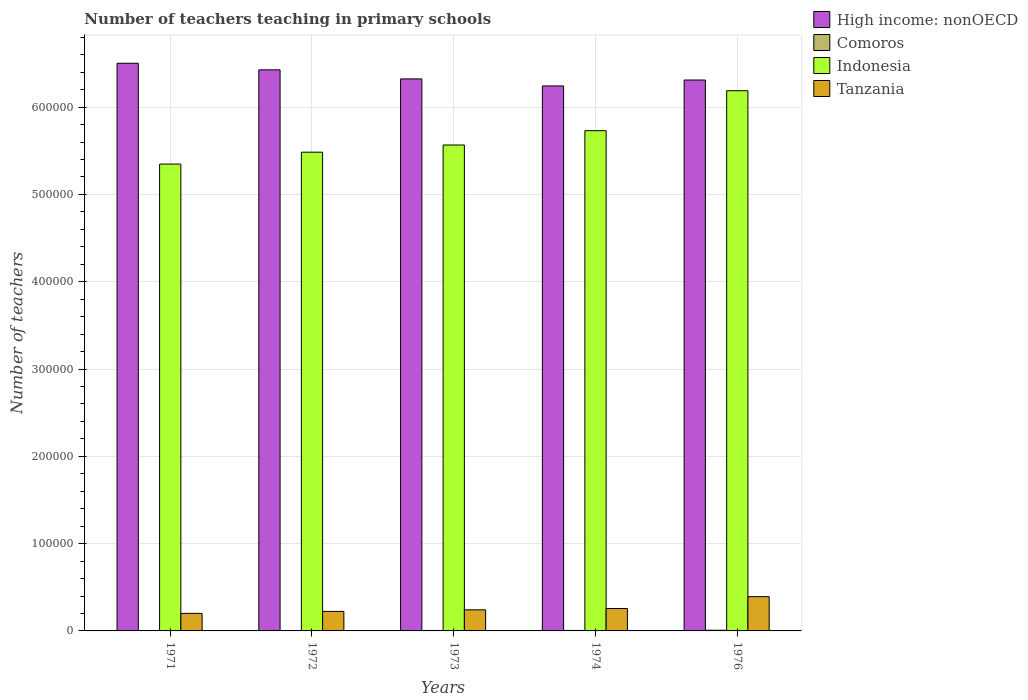Are the number of bars per tick equal to the number of legend labels?
Offer a terse response. Yes. Are the number of bars on each tick of the X-axis equal?
Provide a short and direct response. Yes. What is the label of the 2nd group of bars from the left?
Provide a short and direct response. 1972. In how many cases, is the number of bars for a given year not equal to the number of legend labels?
Ensure brevity in your answer.  0. What is the number of teachers teaching in primary schools in Comoros in 1972?
Provide a succinct answer. 396. Across all years, what is the maximum number of teachers teaching in primary schools in Indonesia?
Give a very brief answer. 6.19e+05. Across all years, what is the minimum number of teachers teaching in primary schools in Comoros?
Your answer should be compact. 361. In which year was the number of teachers teaching in primary schools in Indonesia maximum?
Your answer should be compact. 1976. What is the total number of teachers teaching in primary schools in High income: nonOECD in the graph?
Provide a short and direct response. 3.18e+06. What is the difference between the number of teachers teaching in primary schools in Comoros in 1971 and that in 1973?
Provide a succinct answer. -172. What is the difference between the number of teachers teaching in primary schools in Tanzania in 1976 and the number of teachers teaching in primary schools in High income: nonOECD in 1974?
Your answer should be compact. -5.85e+05. What is the average number of teachers teaching in primary schools in High income: nonOECD per year?
Your answer should be compact. 6.36e+05. In the year 1972, what is the difference between the number of teachers teaching in primary schools in Tanzania and number of teachers teaching in primary schools in High income: nonOECD?
Offer a terse response. -6.20e+05. What is the ratio of the number of teachers teaching in primary schools in Tanzania in 1972 to that in 1974?
Offer a very short reply. 0.87. Is the difference between the number of teachers teaching in primary schools in Tanzania in 1973 and 1976 greater than the difference between the number of teachers teaching in primary schools in High income: nonOECD in 1973 and 1976?
Ensure brevity in your answer.  No. What is the difference between the highest and the second highest number of teachers teaching in primary schools in Comoros?
Offer a very short reply. 202. What is the difference between the highest and the lowest number of teachers teaching in primary schools in Tanzania?
Keep it short and to the point. 1.92e+04. What does the 2nd bar from the left in 1972 represents?
Provide a short and direct response. Comoros. What does the 4th bar from the right in 1971 represents?
Provide a succinct answer. High income: nonOECD. Are all the bars in the graph horizontal?
Ensure brevity in your answer.  No. How many years are there in the graph?
Make the answer very short. 5. Are the values on the major ticks of Y-axis written in scientific E-notation?
Provide a short and direct response. No. Does the graph contain any zero values?
Provide a short and direct response. No. Where does the legend appear in the graph?
Your response must be concise. Top right. How many legend labels are there?
Your response must be concise. 4. What is the title of the graph?
Provide a short and direct response. Number of teachers teaching in primary schools. What is the label or title of the X-axis?
Your answer should be very brief. Years. What is the label or title of the Y-axis?
Keep it short and to the point. Number of teachers. What is the Number of teachers in High income: nonOECD in 1971?
Your answer should be compact. 6.50e+05. What is the Number of teachers in Comoros in 1971?
Make the answer very short. 361. What is the Number of teachers in Indonesia in 1971?
Your answer should be very brief. 5.35e+05. What is the Number of teachers of Tanzania in 1971?
Your response must be concise. 2.01e+04. What is the Number of teachers in High income: nonOECD in 1972?
Your answer should be compact. 6.43e+05. What is the Number of teachers in Comoros in 1972?
Keep it short and to the point. 396. What is the Number of teachers in Indonesia in 1972?
Make the answer very short. 5.48e+05. What is the Number of teachers of Tanzania in 1972?
Provide a succinct answer. 2.24e+04. What is the Number of teachers in High income: nonOECD in 1973?
Keep it short and to the point. 6.32e+05. What is the Number of teachers in Comoros in 1973?
Provide a succinct answer. 533. What is the Number of teachers of Indonesia in 1973?
Offer a very short reply. 5.57e+05. What is the Number of teachers of Tanzania in 1973?
Ensure brevity in your answer.  2.42e+04. What is the Number of teachers of High income: nonOECD in 1974?
Keep it short and to the point. 6.24e+05. What is the Number of teachers of Comoros in 1974?
Provide a short and direct response. 554. What is the Number of teachers of Indonesia in 1974?
Keep it short and to the point. 5.73e+05. What is the Number of teachers in Tanzania in 1974?
Offer a terse response. 2.57e+04. What is the Number of teachers in High income: nonOECD in 1976?
Your response must be concise. 6.31e+05. What is the Number of teachers of Comoros in 1976?
Ensure brevity in your answer.  756. What is the Number of teachers of Indonesia in 1976?
Make the answer very short. 6.19e+05. What is the Number of teachers in Tanzania in 1976?
Provide a short and direct response. 3.92e+04. Across all years, what is the maximum Number of teachers of High income: nonOECD?
Give a very brief answer. 6.50e+05. Across all years, what is the maximum Number of teachers in Comoros?
Provide a succinct answer. 756. Across all years, what is the maximum Number of teachers of Indonesia?
Keep it short and to the point. 6.19e+05. Across all years, what is the maximum Number of teachers in Tanzania?
Provide a short and direct response. 3.92e+04. Across all years, what is the minimum Number of teachers in High income: nonOECD?
Provide a succinct answer. 6.24e+05. Across all years, what is the minimum Number of teachers in Comoros?
Provide a succinct answer. 361. Across all years, what is the minimum Number of teachers of Indonesia?
Ensure brevity in your answer.  5.35e+05. Across all years, what is the minimum Number of teachers in Tanzania?
Ensure brevity in your answer.  2.01e+04. What is the total Number of teachers of High income: nonOECD in the graph?
Keep it short and to the point. 3.18e+06. What is the total Number of teachers in Comoros in the graph?
Ensure brevity in your answer.  2600. What is the total Number of teachers of Indonesia in the graph?
Give a very brief answer. 2.83e+06. What is the total Number of teachers of Tanzania in the graph?
Give a very brief answer. 1.32e+05. What is the difference between the Number of teachers of High income: nonOECD in 1971 and that in 1972?
Give a very brief answer. 7545.62. What is the difference between the Number of teachers of Comoros in 1971 and that in 1972?
Provide a succinct answer. -35. What is the difference between the Number of teachers in Indonesia in 1971 and that in 1972?
Offer a very short reply. -1.36e+04. What is the difference between the Number of teachers in Tanzania in 1971 and that in 1972?
Ensure brevity in your answer.  -2266. What is the difference between the Number of teachers in High income: nonOECD in 1971 and that in 1973?
Your answer should be compact. 1.79e+04. What is the difference between the Number of teachers of Comoros in 1971 and that in 1973?
Keep it short and to the point. -172. What is the difference between the Number of teachers of Indonesia in 1971 and that in 1973?
Make the answer very short. -2.19e+04. What is the difference between the Number of teachers in Tanzania in 1971 and that in 1973?
Give a very brief answer. -4074. What is the difference between the Number of teachers in High income: nonOECD in 1971 and that in 1974?
Your response must be concise. 2.60e+04. What is the difference between the Number of teachers of Comoros in 1971 and that in 1974?
Your answer should be compact. -193. What is the difference between the Number of teachers of Indonesia in 1971 and that in 1974?
Offer a terse response. -3.83e+04. What is the difference between the Number of teachers in Tanzania in 1971 and that in 1974?
Your response must be concise. -5594. What is the difference between the Number of teachers in High income: nonOECD in 1971 and that in 1976?
Make the answer very short. 1.92e+04. What is the difference between the Number of teachers of Comoros in 1971 and that in 1976?
Make the answer very short. -395. What is the difference between the Number of teachers of Indonesia in 1971 and that in 1976?
Provide a short and direct response. -8.40e+04. What is the difference between the Number of teachers in Tanzania in 1971 and that in 1976?
Offer a terse response. -1.92e+04. What is the difference between the Number of teachers in High income: nonOECD in 1972 and that in 1973?
Provide a succinct answer. 1.04e+04. What is the difference between the Number of teachers in Comoros in 1972 and that in 1973?
Offer a very short reply. -137. What is the difference between the Number of teachers of Indonesia in 1972 and that in 1973?
Offer a terse response. -8228. What is the difference between the Number of teachers in Tanzania in 1972 and that in 1973?
Make the answer very short. -1808. What is the difference between the Number of teachers in High income: nonOECD in 1972 and that in 1974?
Offer a very short reply. 1.85e+04. What is the difference between the Number of teachers in Comoros in 1972 and that in 1974?
Provide a succinct answer. -158. What is the difference between the Number of teachers in Indonesia in 1972 and that in 1974?
Offer a terse response. -2.46e+04. What is the difference between the Number of teachers in Tanzania in 1972 and that in 1974?
Your answer should be compact. -3328. What is the difference between the Number of teachers of High income: nonOECD in 1972 and that in 1976?
Offer a very short reply. 1.17e+04. What is the difference between the Number of teachers in Comoros in 1972 and that in 1976?
Your answer should be very brief. -360. What is the difference between the Number of teachers in Indonesia in 1972 and that in 1976?
Your response must be concise. -7.04e+04. What is the difference between the Number of teachers of Tanzania in 1972 and that in 1976?
Keep it short and to the point. -1.69e+04. What is the difference between the Number of teachers of High income: nonOECD in 1973 and that in 1974?
Your answer should be very brief. 8076.81. What is the difference between the Number of teachers in Comoros in 1973 and that in 1974?
Make the answer very short. -21. What is the difference between the Number of teachers of Indonesia in 1973 and that in 1974?
Offer a terse response. -1.64e+04. What is the difference between the Number of teachers of Tanzania in 1973 and that in 1974?
Offer a terse response. -1520. What is the difference between the Number of teachers in High income: nonOECD in 1973 and that in 1976?
Offer a very short reply. 1283.31. What is the difference between the Number of teachers in Comoros in 1973 and that in 1976?
Give a very brief answer. -223. What is the difference between the Number of teachers in Indonesia in 1973 and that in 1976?
Provide a short and direct response. -6.22e+04. What is the difference between the Number of teachers of Tanzania in 1973 and that in 1976?
Your answer should be very brief. -1.51e+04. What is the difference between the Number of teachers of High income: nonOECD in 1974 and that in 1976?
Your answer should be very brief. -6793.5. What is the difference between the Number of teachers of Comoros in 1974 and that in 1976?
Give a very brief answer. -202. What is the difference between the Number of teachers in Indonesia in 1974 and that in 1976?
Offer a very short reply. -4.58e+04. What is the difference between the Number of teachers of Tanzania in 1974 and that in 1976?
Offer a very short reply. -1.36e+04. What is the difference between the Number of teachers in High income: nonOECD in 1971 and the Number of teachers in Comoros in 1972?
Offer a terse response. 6.50e+05. What is the difference between the Number of teachers in High income: nonOECD in 1971 and the Number of teachers in Indonesia in 1972?
Ensure brevity in your answer.  1.02e+05. What is the difference between the Number of teachers of High income: nonOECD in 1971 and the Number of teachers of Tanzania in 1972?
Offer a very short reply. 6.28e+05. What is the difference between the Number of teachers in Comoros in 1971 and the Number of teachers in Indonesia in 1972?
Your answer should be very brief. -5.48e+05. What is the difference between the Number of teachers of Comoros in 1971 and the Number of teachers of Tanzania in 1972?
Ensure brevity in your answer.  -2.20e+04. What is the difference between the Number of teachers of Indonesia in 1971 and the Number of teachers of Tanzania in 1972?
Your response must be concise. 5.12e+05. What is the difference between the Number of teachers in High income: nonOECD in 1971 and the Number of teachers in Comoros in 1973?
Give a very brief answer. 6.50e+05. What is the difference between the Number of teachers in High income: nonOECD in 1971 and the Number of teachers in Indonesia in 1973?
Your answer should be very brief. 9.36e+04. What is the difference between the Number of teachers of High income: nonOECD in 1971 and the Number of teachers of Tanzania in 1973?
Your response must be concise. 6.26e+05. What is the difference between the Number of teachers of Comoros in 1971 and the Number of teachers of Indonesia in 1973?
Make the answer very short. -5.56e+05. What is the difference between the Number of teachers in Comoros in 1971 and the Number of teachers in Tanzania in 1973?
Provide a succinct answer. -2.38e+04. What is the difference between the Number of teachers of Indonesia in 1971 and the Number of teachers of Tanzania in 1973?
Your answer should be compact. 5.11e+05. What is the difference between the Number of teachers in High income: nonOECD in 1971 and the Number of teachers in Comoros in 1974?
Provide a short and direct response. 6.50e+05. What is the difference between the Number of teachers of High income: nonOECD in 1971 and the Number of teachers of Indonesia in 1974?
Make the answer very short. 7.72e+04. What is the difference between the Number of teachers of High income: nonOECD in 1971 and the Number of teachers of Tanzania in 1974?
Ensure brevity in your answer.  6.25e+05. What is the difference between the Number of teachers of Comoros in 1971 and the Number of teachers of Indonesia in 1974?
Provide a succinct answer. -5.73e+05. What is the difference between the Number of teachers in Comoros in 1971 and the Number of teachers in Tanzania in 1974?
Your answer should be compact. -2.53e+04. What is the difference between the Number of teachers of Indonesia in 1971 and the Number of teachers of Tanzania in 1974?
Your answer should be very brief. 5.09e+05. What is the difference between the Number of teachers of High income: nonOECD in 1971 and the Number of teachers of Comoros in 1976?
Offer a terse response. 6.50e+05. What is the difference between the Number of teachers in High income: nonOECD in 1971 and the Number of teachers in Indonesia in 1976?
Keep it short and to the point. 3.15e+04. What is the difference between the Number of teachers in High income: nonOECD in 1971 and the Number of teachers in Tanzania in 1976?
Give a very brief answer. 6.11e+05. What is the difference between the Number of teachers of Comoros in 1971 and the Number of teachers of Indonesia in 1976?
Provide a succinct answer. -6.18e+05. What is the difference between the Number of teachers of Comoros in 1971 and the Number of teachers of Tanzania in 1976?
Your answer should be very brief. -3.89e+04. What is the difference between the Number of teachers in Indonesia in 1971 and the Number of teachers in Tanzania in 1976?
Give a very brief answer. 4.96e+05. What is the difference between the Number of teachers in High income: nonOECD in 1972 and the Number of teachers in Comoros in 1973?
Provide a succinct answer. 6.42e+05. What is the difference between the Number of teachers in High income: nonOECD in 1972 and the Number of teachers in Indonesia in 1973?
Provide a short and direct response. 8.61e+04. What is the difference between the Number of teachers of High income: nonOECD in 1972 and the Number of teachers of Tanzania in 1973?
Your answer should be compact. 6.19e+05. What is the difference between the Number of teachers in Comoros in 1972 and the Number of teachers in Indonesia in 1973?
Offer a very short reply. -5.56e+05. What is the difference between the Number of teachers in Comoros in 1972 and the Number of teachers in Tanzania in 1973?
Make the answer very short. -2.38e+04. What is the difference between the Number of teachers in Indonesia in 1972 and the Number of teachers in Tanzania in 1973?
Give a very brief answer. 5.24e+05. What is the difference between the Number of teachers in High income: nonOECD in 1972 and the Number of teachers in Comoros in 1974?
Your answer should be compact. 6.42e+05. What is the difference between the Number of teachers in High income: nonOECD in 1972 and the Number of teachers in Indonesia in 1974?
Your answer should be very brief. 6.97e+04. What is the difference between the Number of teachers in High income: nonOECD in 1972 and the Number of teachers in Tanzania in 1974?
Make the answer very short. 6.17e+05. What is the difference between the Number of teachers of Comoros in 1972 and the Number of teachers of Indonesia in 1974?
Offer a terse response. -5.73e+05. What is the difference between the Number of teachers of Comoros in 1972 and the Number of teachers of Tanzania in 1974?
Keep it short and to the point. -2.53e+04. What is the difference between the Number of teachers of Indonesia in 1972 and the Number of teachers of Tanzania in 1974?
Offer a very short reply. 5.23e+05. What is the difference between the Number of teachers of High income: nonOECD in 1972 and the Number of teachers of Comoros in 1976?
Your response must be concise. 6.42e+05. What is the difference between the Number of teachers in High income: nonOECD in 1972 and the Number of teachers in Indonesia in 1976?
Your answer should be very brief. 2.39e+04. What is the difference between the Number of teachers in High income: nonOECD in 1972 and the Number of teachers in Tanzania in 1976?
Give a very brief answer. 6.04e+05. What is the difference between the Number of teachers in Comoros in 1972 and the Number of teachers in Indonesia in 1976?
Give a very brief answer. -6.18e+05. What is the difference between the Number of teachers of Comoros in 1972 and the Number of teachers of Tanzania in 1976?
Your answer should be compact. -3.88e+04. What is the difference between the Number of teachers of Indonesia in 1972 and the Number of teachers of Tanzania in 1976?
Make the answer very short. 5.09e+05. What is the difference between the Number of teachers in High income: nonOECD in 1973 and the Number of teachers in Comoros in 1974?
Provide a succinct answer. 6.32e+05. What is the difference between the Number of teachers in High income: nonOECD in 1973 and the Number of teachers in Indonesia in 1974?
Offer a very short reply. 5.93e+04. What is the difference between the Number of teachers in High income: nonOECD in 1973 and the Number of teachers in Tanzania in 1974?
Give a very brief answer. 6.07e+05. What is the difference between the Number of teachers in Comoros in 1973 and the Number of teachers in Indonesia in 1974?
Keep it short and to the point. -5.73e+05. What is the difference between the Number of teachers of Comoros in 1973 and the Number of teachers of Tanzania in 1974?
Your response must be concise. -2.52e+04. What is the difference between the Number of teachers in Indonesia in 1973 and the Number of teachers in Tanzania in 1974?
Provide a succinct answer. 5.31e+05. What is the difference between the Number of teachers in High income: nonOECD in 1973 and the Number of teachers in Comoros in 1976?
Provide a short and direct response. 6.32e+05. What is the difference between the Number of teachers of High income: nonOECD in 1973 and the Number of teachers of Indonesia in 1976?
Your answer should be compact. 1.35e+04. What is the difference between the Number of teachers in High income: nonOECD in 1973 and the Number of teachers in Tanzania in 1976?
Ensure brevity in your answer.  5.93e+05. What is the difference between the Number of teachers of Comoros in 1973 and the Number of teachers of Indonesia in 1976?
Make the answer very short. -6.18e+05. What is the difference between the Number of teachers in Comoros in 1973 and the Number of teachers in Tanzania in 1976?
Keep it short and to the point. -3.87e+04. What is the difference between the Number of teachers in Indonesia in 1973 and the Number of teachers in Tanzania in 1976?
Make the answer very short. 5.17e+05. What is the difference between the Number of teachers in High income: nonOECD in 1974 and the Number of teachers in Comoros in 1976?
Offer a very short reply. 6.24e+05. What is the difference between the Number of teachers of High income: nonOECD in 1974 and the Number of teachers of Indonesia in 1976?
Ensure brevity in your answer.  5467.06. What is the difference between the Number of teachers in High income: nonOECD in 1974 and the Number of teachers in Tanzania in 1976?
Your response must be concise. 5.85e+05. What is the difference between the Number of teachers of Comoros in 1974 and the Number of teachers of Indonesia in 1976?
Ensure brevity in your answer.  -6.18e+05. What is the difference between the Number of teachers in Comoros in 1974 and the Number of teachers in Tanzania in 1976?
Offer a terse response. -3.87e+04. What is the difference between the Number of teachers of Indonesia in 1974 and the Number of teachers of Tanzania in 1976?
Make the answer very short. 5.34e+05. What is the average Number of teachers of High income: nonOECD per year?
Make the answer very short. 6.36e+05. What is the average Number of teachers in Comoros per year?
Your response must be concise. 520. What is the average Number of teachers in Indonesia per year?
Make the answer very short. 5.66e+05. What is the average Number of teachers in Tanzania per year?
Your answer should be compact. 2.63e+04. In the year 1971, what is the difference between the Number of teachers in High income: nonOECD and Number of teachers in Comoros?
Provide a short and direct response. 6.50e+05. In the year 1971, what is the difference between the Number of teachers in High income: nonOECD and Number of teachers in Indonesia?
Make the answer very short. 1.15e+05. In the year 1971, what is the difference between the Number of teachers in High income: nonOECD and Number of teachers in Tanzania?
Provide a succinct answer. 6.30e+05. In the year 1971, what is the difference between the Number of teachers in Comoros and Number of teachers in Indonesia?
Your response must be concise. -5.34e+05. In the year 1971, what is the difference between the Number of teachers of Comoros and Number of teachers of Tanzania?
Your answer should be very brief. -1.97e+04. In the year 1971, what is the difference between the Number of teachers in Indonesia and Number of teachers in Tanzania?
Your answer should be very brief. 5.15e+05. In the year 1972, what is the difference between the Number of teachers in High income: nonOECD and Number of teachers in Comoros?
Your answer should be very brief. 6.42e+05. In the year 1972, what is the difference between the Number of teachers in High income: nonOECD and Number of teachers in Indonesia?
Your response must be concise. 9.43e+04. In the year 1972, what is the difference between the Number of teachers in High income: nonOECD and Number of teachers in Tanzania?
Your answer should be very brief. 6.20e+05. In the year 1972, what is the difference between the Number of teachers of Comoros and Number of teachers of Indonesia?
Your answer should be very brief. -5.48e+05. In the year 1972, what is the difference between the Number of teachers of Comoros and Number of teachers of Tanzania?
Give a very brief answer. -2.20e+04. In the year 1972, what is the difference between the Number of teachers of Indonesia and Number of teachers of Tanzania?
Your answer should be compact. 5.26e+05. In the year 1973, what is the difference between the Number of teachers in High income: nonOECD and Number of teachers in Comoros?
Provide a succinct answer. 6.32e+05. In the year 1973, what is the difference between the Number of teachers in High income: nonOECD and Number of teachers in Indonesia?
Give a very brief answer. 7.57e+04. In the year 1973, what is the difference between the Number of teachers in High income: nonOECD and Number of teachers in Tanzania?
Provide a succinct answer. 6.08e+05. In the year 1973, what is the difference between the Number of teachers in Comoros and Number of teachers in Indonesia?
Offer a terse response. -5.56e+05. In the year 1973, what is the difference between the Number of teachers of Comoros and Number of teachers of Tanzania?
Offer a terse response. -2.36e+04. In the year 1973, what is the difference between the Number of teachers of Indonesia and Number of teachers of Tanzania?
Keep it short and to the point. 5.32e+05. In the year 1974, what is the difference between the Number of teachers in High income: nonOECD and Number of teachers in Comoros?
Give a very brief answer. 6.24e+05. In the year 1974, what is the difference between the Number of teachers in High income: nonOECD and Number of teachers in Indonesia?
Your answer should be very brief. 5.12e+04. In the year 1974, what is the difference between the Number of teachers of High income: nonOECD and Number of teachers of Tanzania?
Make the answer very short. 5.99e+05. In the year 1974, what is the difference between the Number of teachers in Comoros and Number of teachers in Indonesia?
Make the answer very short. -5.73e+05. In the year 1974, what is the difference between the Number of teachers of Comoros and Number of teachers of Tanzania?
Provide a succinct answer. -2.51e+04. In the year 1974, what is the difference between the Number of teachers of Indonesia and Number of teachers of Tanzania?
Make the answer very short. 5.47e+05. In the year 1976, what is the difference between the Number of teachers of High income: nonOECD and Number of teachers of Comoros?
Offer a terse response. 6.30e+05. In the year 1976, what is the difference between the Number of teachers of High income: nonOECD and Number of teachers of Indonesia?
Your answer should be very brief. 1.23e+04. In the year 1976, what is the difference between the Number of teachers in High income: nonOECD and Number of teachers in Tanzania?
Give a very brief answer. 5.92e+05. In the year 1976, what is the difference between the Number of teachers of Comoros and Number of teachers of Indonesia?
Offer a very short reply. -6.18e+05. In the year 1976, what is the difference between the Number of teachers in Comoros and Number of teachers in Tanzania?
Your answer should be very brief. -3.85e+04. In the year 1976, what is the difference between the Number of teachers of Indonesia and Number of teachers of Tanzania?
Ensure brevity in your answer.  5.80e+05. What is the ratio of the Number of teachers in High income: nonOECD in 1971 to that in 1972?
Give a very brief answer. 1.01. What is the ratio of the Number of teachers of Comoros in 1971 to that in 1972?
Your answer should be very brief. 0.91. What is the ratio of the Number of teachers of Indonesia in 1971 to that in 1972?
Provide a short and direct response. 0.98. What is the ratio of the Number of teachers of Tanzania in 1971 to that in 1972?
Provide a succinct answer. 0.9. What is the ratio of the Number of teachers of High income: nonOECD in 1971 to that in 1973?
Your answer should be compact. 1.03. What is the ratio of the Number of teachers of Comoros in 1971 to that in 1973?
Provide a short and direct response. 0.68. What is the ratio of the Number of teachers of Indonesia in 1971 to that in 1973?
Offer a terse response. 0.96. What is the ratio of the Number of teachers in Tanzania in 1971 to that in 1973?
Keep it short and to the point. 0.83. What is the ratio of the Number of teachers of High income: nonOECD in 1971 to that in 1974?
Offer a very short reply. 1.04. What is the ratio of the Number of teachers of Comoros in 1971 to that in 1974?
Make the answer very short. 0.65. What is the ratio of the Number of teachers in Indonesia in 1971 to that in 1974?
Your response must be concise. 0.93. What is the ratio of the Number of teachers of Tanzania in 1971 to that in 1974?
Give a very brief answer. 0.78. What is the ratio of the Number of teachers of High income: nonOECD in 1971 to that in 1976?
Your answer should be compact. 1.03. What is the ratio of the Number of teachers in Comoros in 1971 to that in 1976?
Keep it short and to the point. 0.48. What is the ratio of the Number of teachers in Indonesia in 1971 to that in 1976?
Provide a succinct answer. 0.86. What is the ratio of the Number of teachers in Tanzania in 1971 to that in 1976?
Ensure brevity in your answer.  0.51. What is the ratio of the Number of teachers of High income: nonOECD in 1972 to that in 1973?
Ensure brevity in your answer.  1.02. What is the ratio of the Number of teachers in Comoros in 1972 to that in 1973?
Give a very brief answer. 0.74. What is the ratio of the Number of teachers in Indonesia in 1972 to that in 1973?
Give a very brief answer. 0.99. What is the ratio of the Number of teachers in Tanzania in 1972 to that in 1973?
Give a very brief answer. 0.93. What is the ratio of the Number of teachers in High income: nonOECD in 1972 to that in 1974?
Give a very brief answer. 1.03. What is the ratio of the Number of teachers in Comoros in 1972 to that in 1974?
Your response must be concise. 0.71. What is the ratio of the Number of teachers in Indonesia in 1972 to that in 1974?
Provide a short and direct response. 0.96. What is the ratio of the Number of teachers of Tanzania in 1972 to that in 1974?
Provide a succinct answer. 0.87. What is the ratio of the Number of teachers in High income: nonOECD in 1972 to that in 1976?
Provide a succinct answer. 1.02. What is the ratio of the Number of teachers in Comoros in 1972 to that in 1976?
Your response must be concise. 0.52. What is the ratio of the Number of teachers of Indonesia in 1972 to that in 1976?
Ensure brevity in your answer.  0.89. What is the ratio of the Number of teachers of Tanzania in 1972 to that in 1976?
Keep it short and to the point. 0.57. What is the ratio of the Number of teachers in High income: nonOECD in 1973 to that in 1974?
Provide a short and direct response. 1.01. What is the ratio of the Number of teachers of Comoros in 1973 to that in 1974?
Offer a terse response. 0.96. What is the ratio of the Number of teachers in Indonesia in 1973 to that in 1974?
Keep it short and to the point. 0.97. What is the ratio of the Number of teachers of Tanzania in 1973 to that in 1974?
Provide a short and direct response. 0.94. What is the ratio of the Number of teachers of High income: nonOECD in 1973 to that in 1976?
Your answer should be compact. 1. What is the ratio of the Number of teachers in Comoros in 1973 to that in 1976?
Provide a succinct answer. 0.7. What is the ratio of the Number of teachers in Indonesia in 1973 to that in 1976?
Make the answer very short. 0.9. What is the ratio of the Number of teachers of Tanzania in 1973 to that in 1976?
Your response must be concise. 0.62. What is the ratio of the Number of teachers of High income: nonOECD in 1974 to that in 1976?
Keep it short and to the point. 0.99. What is the ratio of the Number of teachers in Comoros in 1974 to that in 1976?
Your answer should be very brief. 0.73. What is the ratio of the Number of teachers of Indonesia in 1974 to that in 1976?
Provide a short and direct response. 0.93. What is the ratio of the Number of teachers in Tanzania in 1974 to that in 1976?
Provide a succinct answer. 0.65. What is the difference between the highest and the second highest Number of teachers of High income: nonOECD?
Your response must be concise. 7545.62. What is the difference between the highest and the second highest Number of teachers in Comoros?
Provide a succinct answer. 202. What is the difference between the highest and the second highest Number of teachers in Indonesia?
Ensure brevity in your answer.  4.58e+04. What is the difference between the highest and the second highest Number of teachers of Tanzania?
Make the answer very short. 1.36e+04. What is the difference between the highest and the lowest Number of teachers in High income: nonOECD?
Make the answer very short. 2.60e+04. What is the difference between the highest and the lowest Number of teachers of Comoros?
Make the answer very short. 395. What is the difference between the highest and the lowest Number of teachers in Indonesia?
Keep it short and to the point. 8.40e+04. What is the difference between the highest and the lowest Number of teachers in Tanzania?
Provide a succinct answer. 1.92e+04. 